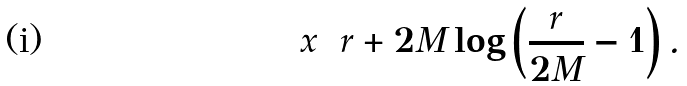Convert formula to latex. <formula><loc_0><loc_0><loc_500><loc_500>x = r + 2 M \log \left ( \frac { r } { 2 M } - 1 \right ) .</formula> 